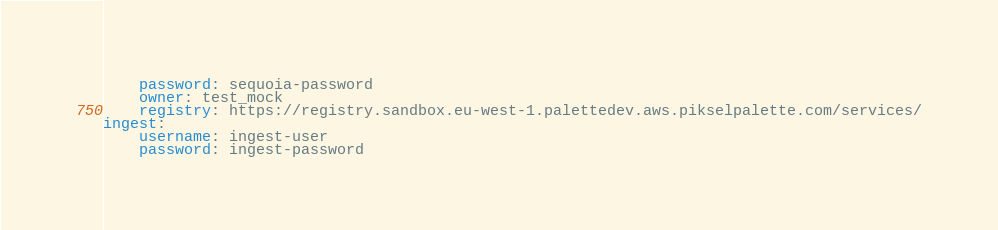Convert code to text. <code><loc_0><loc_0><loc_500><loc_500><_YAML_>    password: sequoia-password
    owner: test_mock
    registry: https://registry.sandbox.eu-west-1.palettedev.aws.pikselpalette.com/services/
ingest:
    username: ingest-user
    password: ingest-password
</code> 